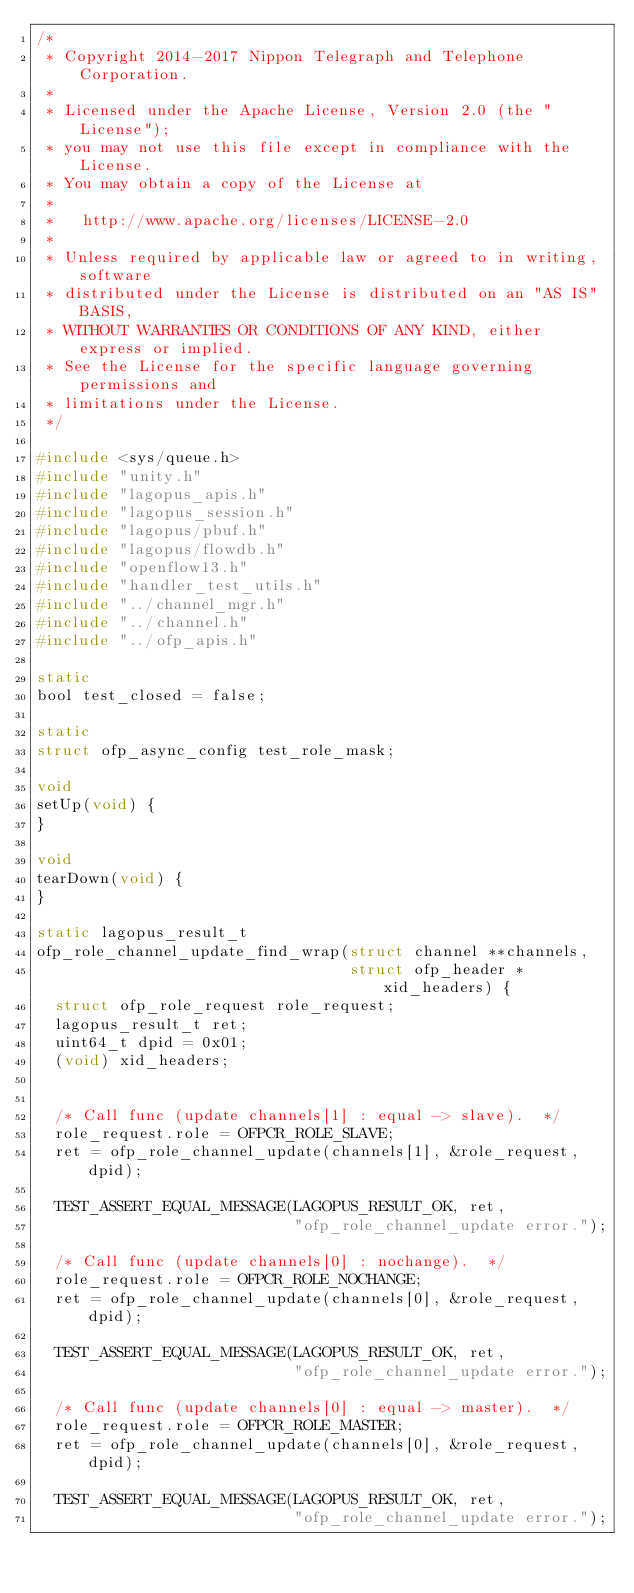<code> <loc_0><loc_0><loc_500><loc_500><_C_>/*
 * Copyright 2014-2017 Nippon Telegraph and Telephone Corporation.
 *
 * Licensed under the Apache License, Version 2.0 (the "License");
 * you may not use this file except in compliance with the License.
 * You may obtain a copy of the License at
 *
 *   http://www.apache.org/licenses/LICENSE-2.0
 *
 * Unless required by applicable law or agreed to in writing, software
 * distributed under the License is distributed on an "AS IS" BASIS,
 * WITHOUT WARRANTIES OR CONDITIONS OF ANY KIND, either express or implied.
 * See the License for the specific language governing permissions and
 * limitations under the License.
 */

#include <sys/queue.h>
#include "unity.h"
#include "lagopus_apis.h"
#include "lagopus_session.h"
#include "lagopus/pbuf.h"
#include "lagopus/flowdb.h"
#include "openflow13.h"
#include "handler_test_utils.h"
#include "../channel_mgr.h"
#include "../channel.h"
#include "../ofp_apis.h"

static
bool test_closed = false;

static
struct ofp_async_config test_role_mask;

void
setUp(void) {
}

void
tearDown(void) {
}

static lagopus_result_t
ofp_role_channel_update_find_wrap(struct channel **channels,
                                  struct ofp_header *xid_headers) {
  struct ofp_role_request role_request;
  lagopus_result_t ret;
  uint64_t dpid = 0x01;
  (void) xid_headers;


  /* Call func (update channels[1] : equal -> slave).  */
  role_request.role = OFPCR_ROLE_SLAVE;
  ret = ofp_role_channel_update(channels[1], &role_request, dpid);

  TEST_ASSERT_EQUAL_MESSAGE(LAGOPUS_RESULT_OK, ret,
                            "ofp_role_channel_update error.");

  /* Call func (update channels[0] : nochange).  */
  role_request.role = OFPCR_ROLE_NOCHANGE;
  ret = ofp_role_channel_update(channels[0], &role_request, dpid);

  TEST_ASSERT_EQUAL_MESSAGE(LAGOPUS_RESULT_OK, ret,
                            "ofp_role_channel_update error.");

  /* Call func (update channels[0] : equal -> master).  */
  role_request.role = OFPCR_ROLE_MASTER;
  ret = ofp_role_channel_update(channels[0], &role_request, dpid);

  TEST_ASSERT_EQUAL_MESSAGE(LAGOPUS_RESULT_OK, ret,
                            "ofp_role_channel_update error.");
</code> 